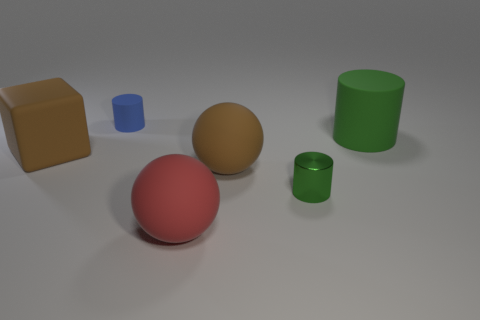What shape is the matte thing that is the same color as the small shiny cylinder?
Offer a terse response. Cylinder. What number of tiny cyan metallic balls are there?
Your answer should be very brief. 0. What number of cylinders are big rubber objects or large yellow matte things?
Keep it short and to the point. 1. There is a cube that is the same size as the green rubber thing; what is its color?
Ensure brevity in your answer.  Brown. How many things are both left of the tiny green metal cylinder and in front of the block?
Your answer should be very brief. 2. What is the material of the tiny blue thing?
Your answer should be compact. Rubber. What number of objects are tiny red shiny balls or big brown blocks?
Your answer should be compact. 1. There is a green object that is behind the big brown block; is it the same size as the brown matte object that is to the right of the big red matte ball?
Ensure brevity in your answer.  Yes. What number of other objects are the same size as the blue rubber thing?
Make the answer very short. 1. How many objects are cylinders in front of the big green object or green cylinders that are to the left of the large green object?
Ensure brevity in your answer.  1. 